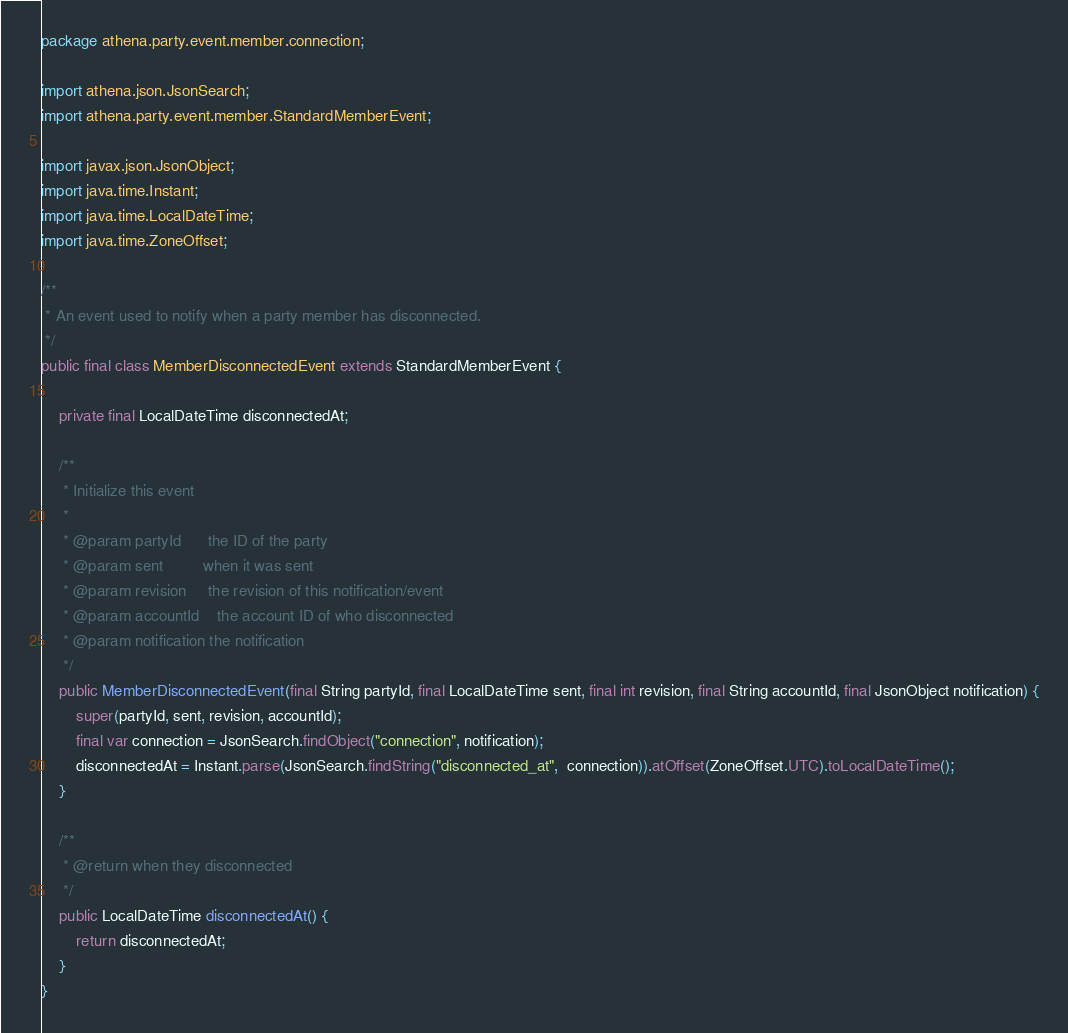Convert code to text. <code><loc_0><loc_0><loc_500><loc_500><_Java_>package athena.party.event.member.connection;

import athena.json.JsonSearch;
import athena.party.event.member.StandardMemberEvent;

import javax.json.JsonObject;
import java.time.Instant;
import java.time.LocalDateTime;
import java.time.ZoneOffset;

/**
 * An event used to notify when a party member has disconnected.
 */
public final class MemberDisconnectedEvent extends StandardMemberEvent {

    private final LocalDateTime disconnectedAt;

    /**
     * Initialize this event
     *
     * @param partyId      the ID of the party
     * @param sent         when it was sent
     * @param revision     the revision of this notification/event
     * @param accountId    the account ID of who disconnected
     * @param notification the notification
     */
    public MemberDisconnectedEvent(final String partyId, final LocalDateTime sent, final int revision, final String accountId, final JsonObject notification) {
        super(partyId, sent, revision, accountId);
        final var connection = JsonSearch.findObject("connection", notification);
        disconnectedAt = Instant.parse(JsonSearch.findString("disconnected_at",  connection)).atOffset(ZoneOffset.UTC).toLocalDateTime();
    }

    /**
     * @return when they disconnected
     */
    public LocalDateTime disconnectedAt() {
        return disconnectedAt;
    }
}
</code> 